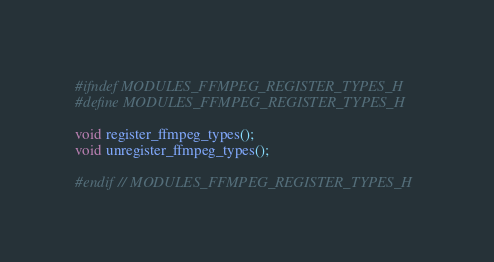<code> <loc_0><loc_0><loc_500><loc_500><_C_>#ifndef MODULES_FFMPEG_REGISTER_TYPES_H
#define MODULES_FFMPEG_REGISTER_TYPES_H

void register_ffmpeg_types();
void unregister_ffmpeg_types();

#endif // MODULES_FFMPEG_REGISTER_TYPES_H
</code> 